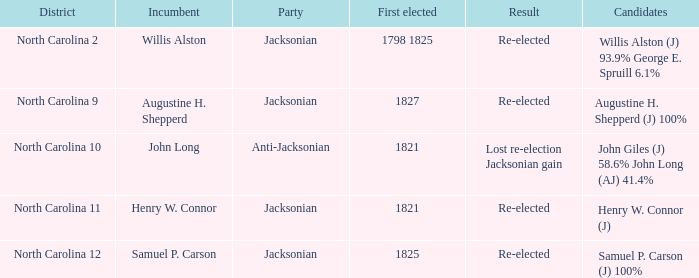What is the overall count of parties for willis alston? 1.0. 